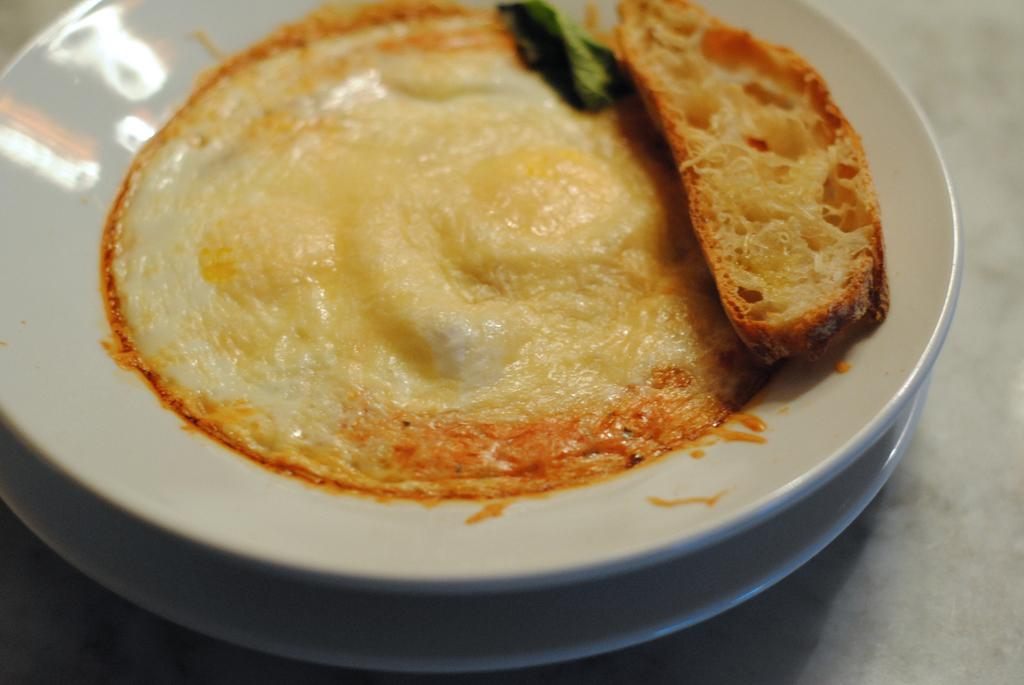How many plates are visible in the image? There are two plates in the image. What is the arrangement of the plates? The plates are stacked one on top of the other. What is on the plate that is on top? The plate on top has food and bread on it. Where are the plates located in the image? The plates are placed on the floor. Can you see any dinosaurs in the image? No, there are no dinosaurs present in the image. 